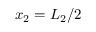<formula> <loc_0><loc_0><loc_500><loc_500>x _ { 2 } = L _ { 2 } / 2</formula> 